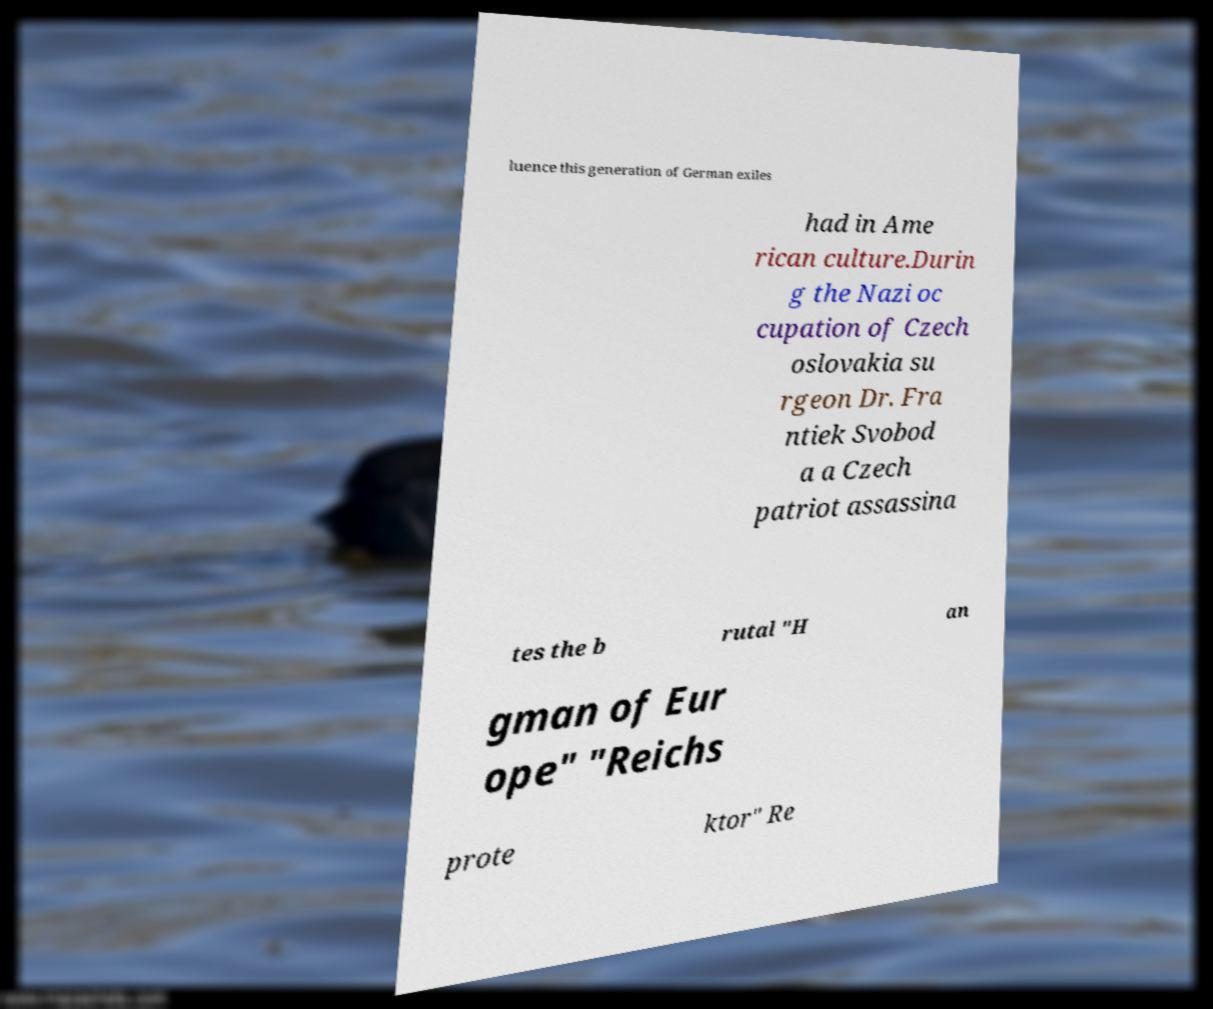What messages or text are displayed in this image? I need them in a readable, typed format. luence this generation of German exiles had in Ame rican culture.Durin g the Nazi oc cupation of Czech oslovakia su rgeon Dr. Fra ntiek Svobod a a Czech patriot assassina tes the b rutal "H an gman of Eur ope" "Reichs prote ktor" Re 